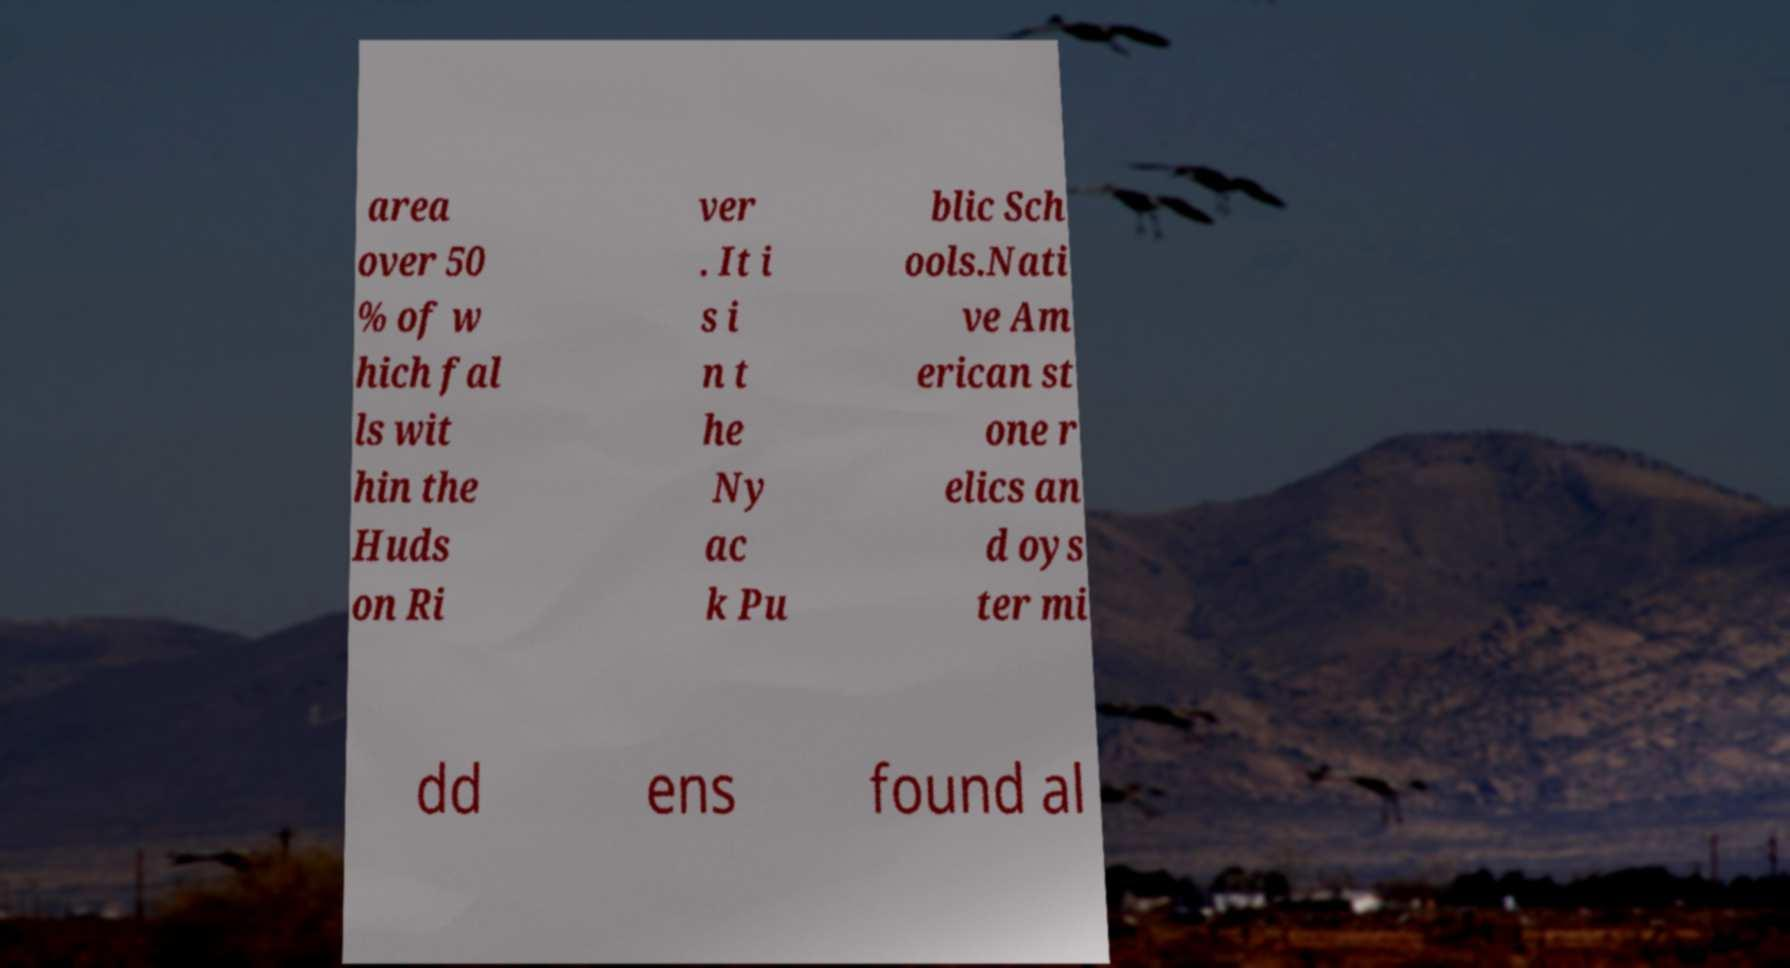For documentation purposes, I need the text within this image transcribed. Could you provide that? area over 50 % of w hich fal ls wit hin the Huds on Ri ver . It i s i n t he Ny ac k Pu blic Sch ools.Nati ve Am erican st one r elics an d oys ter mi dd ens found al 